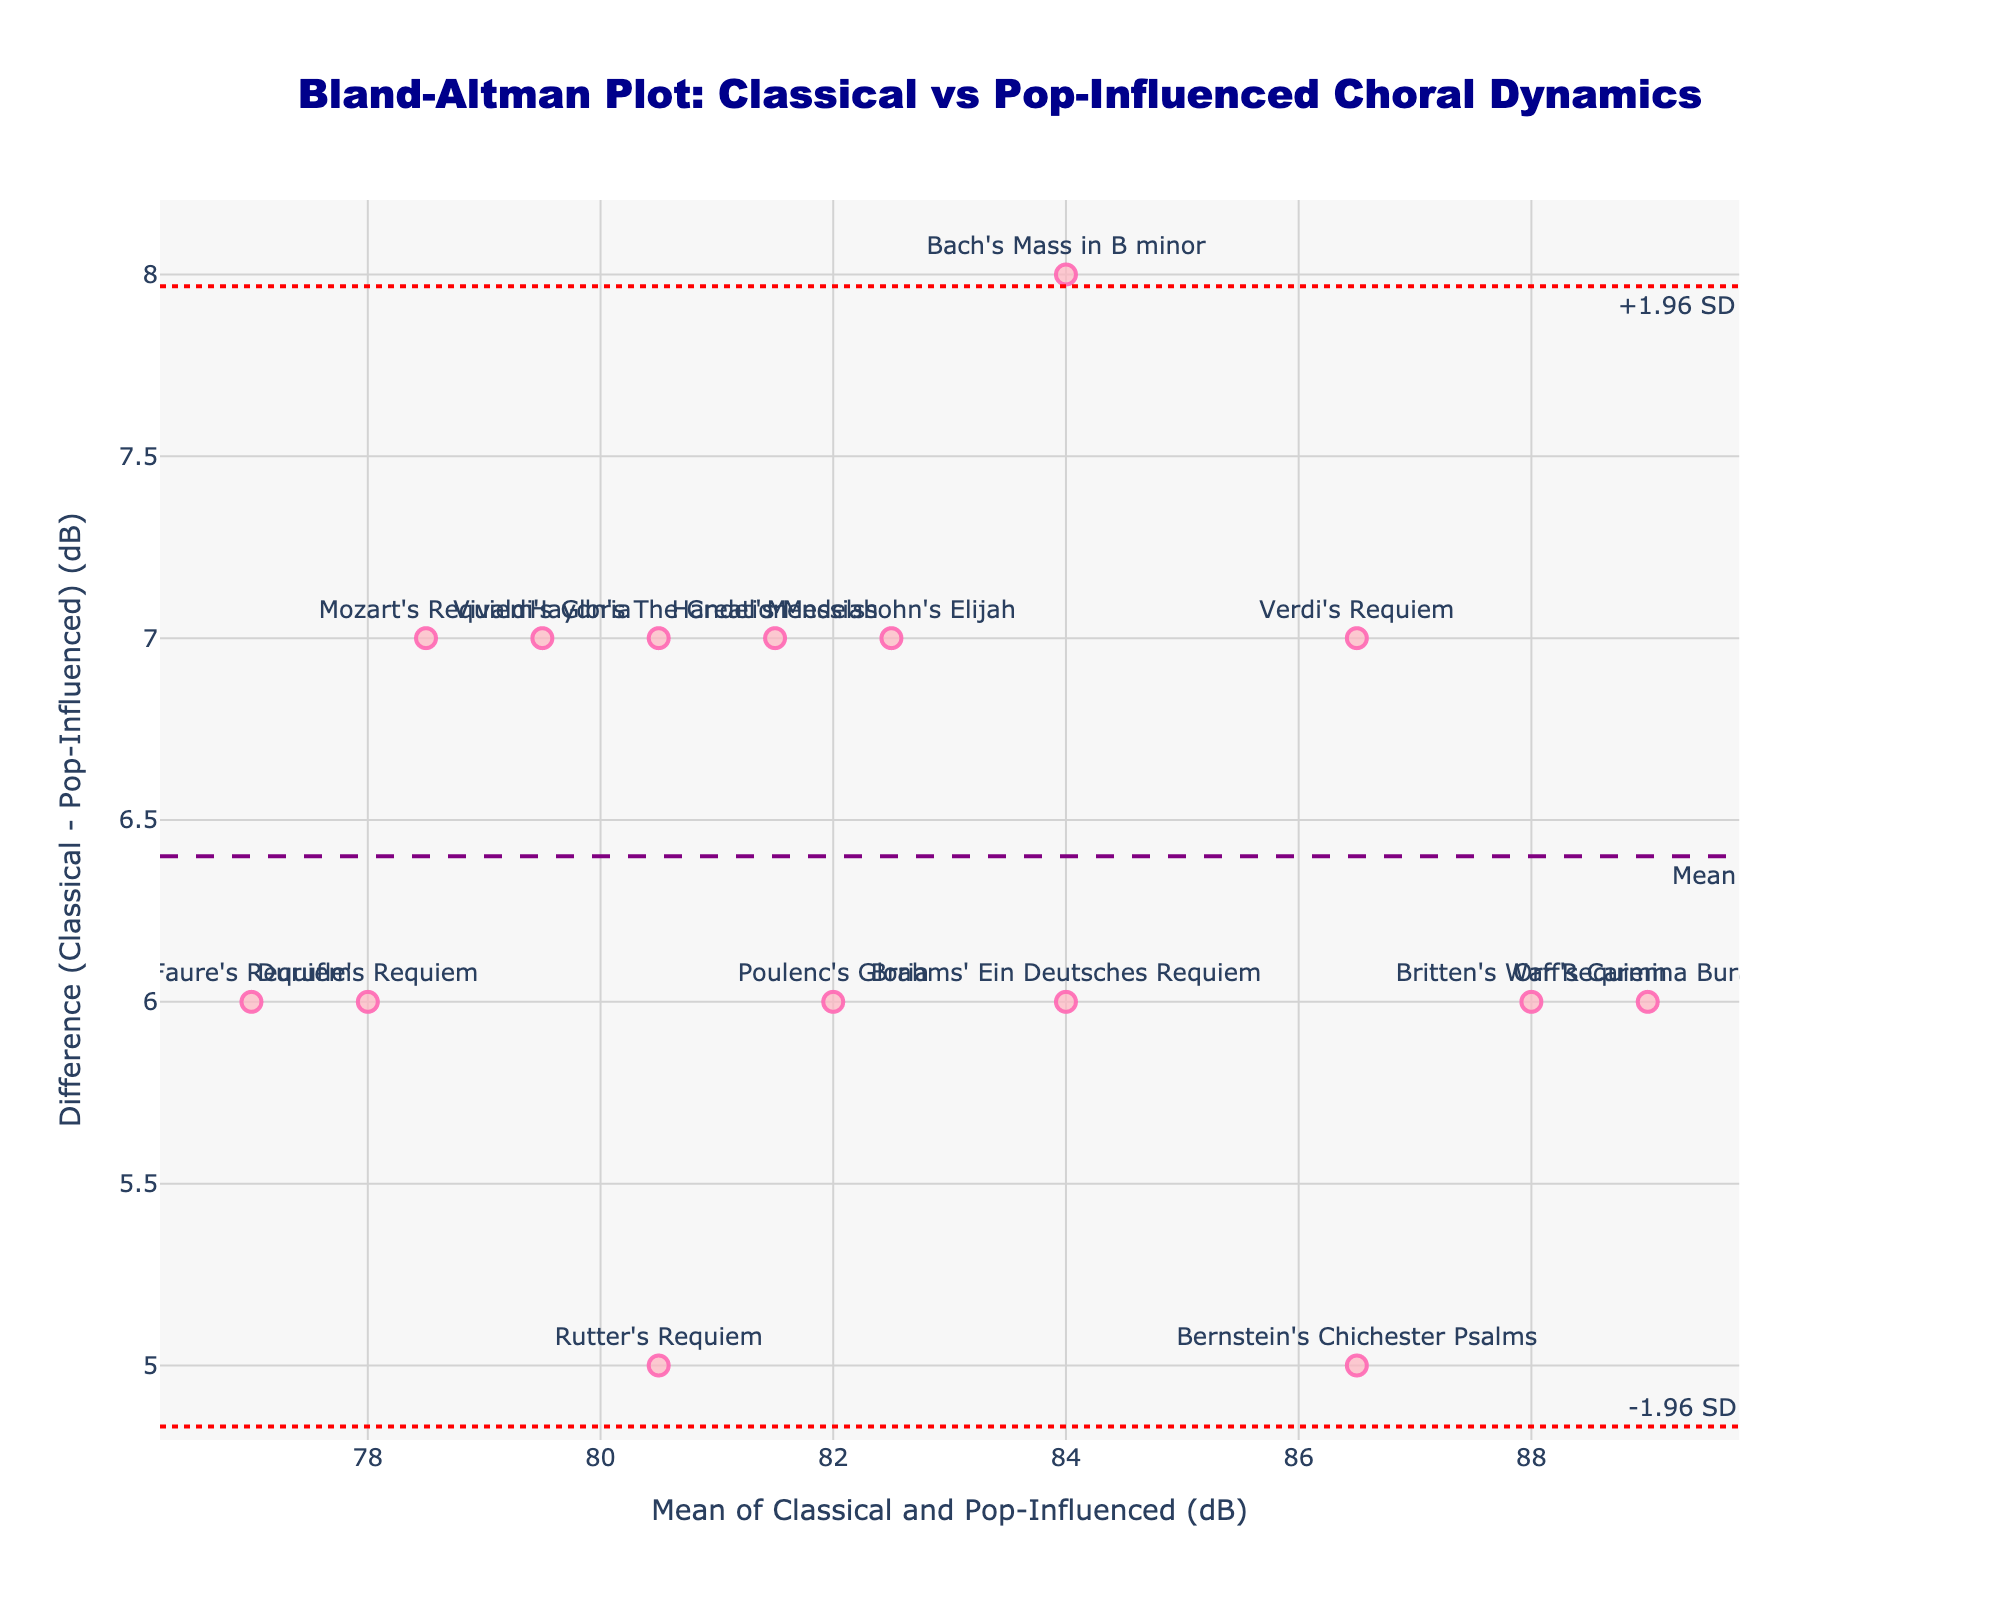What's the title of the plot? The title is clearly stated at the top of the plot. It’s straightforward to identify.
Answer: Bland-Altman Plot: Classical vs Pop-Influenced Choral Dynamics What's the range on the x-axis? The x-axis represents the mean of Classical and Pop-Influenced dynamics, ranging from approximately 75 to 90.
Answer: 75 to 90 What does the dashed purple line represent? The dashed purple line signifies the mean difference between Classical and Pop-Influenced choral dynamics. This line is labeled "Mean" in the plot.
Answer: Mean difference What are the y-values for the +-1.96 SD lines? The plot shows two red dotted lines representing the upper and lower limits of agreement (+1.96 SD and -1.96 SD). By tracing these lines on the plot, we see their approximate y-values.
Answer: +1.96 SD and -1.96 SD How many data points lie outside the +-1.96 SD lines? By visually inspecting the plot, we count the data points outside these limits.
Answer: 0 What’s the mean difference between Classical and Pop-Influenced dynamics? The mean difference is indicated by the horizontal dashed purple line and also mentioned as a Bland-Altman plot feature. Reading the y-value of this line gives the answer.
Answer: Approximately 7 dB Which piece has the highest dynamic range difference favoring Classical? By checking which data point is furthest from the x-axis in a positive direction (y-axis value), we identify the piece.
Answer: Orff's Carmina Burana Which plot point represents Handel's Messiah? Text labels are attached to each data point. Locate "Handel's Messiah" among these labels on the plot.
Answer: The point at (81.5, 7) Compare the variability in dynamics between Classical and Pop versions. Which has more variability? The difference values on the y-axis illustrate how much the Classical dynamics deviate from the Pop dynamics. Since data points spread across positive and negative values but are more consistently above zero, it indicates Classical pieces generally have greater dynamics.
Answer: Classical Is there a general trend in the differences as the mean dynamics increase? By observing the scatter of points, one can infer if differences increase, decrease, or stay the same as mean dynamics increase. The plot shows that differences don't significantly change with mean since there isn’t a noticeable slope or trend.
Answer: No clear trend 